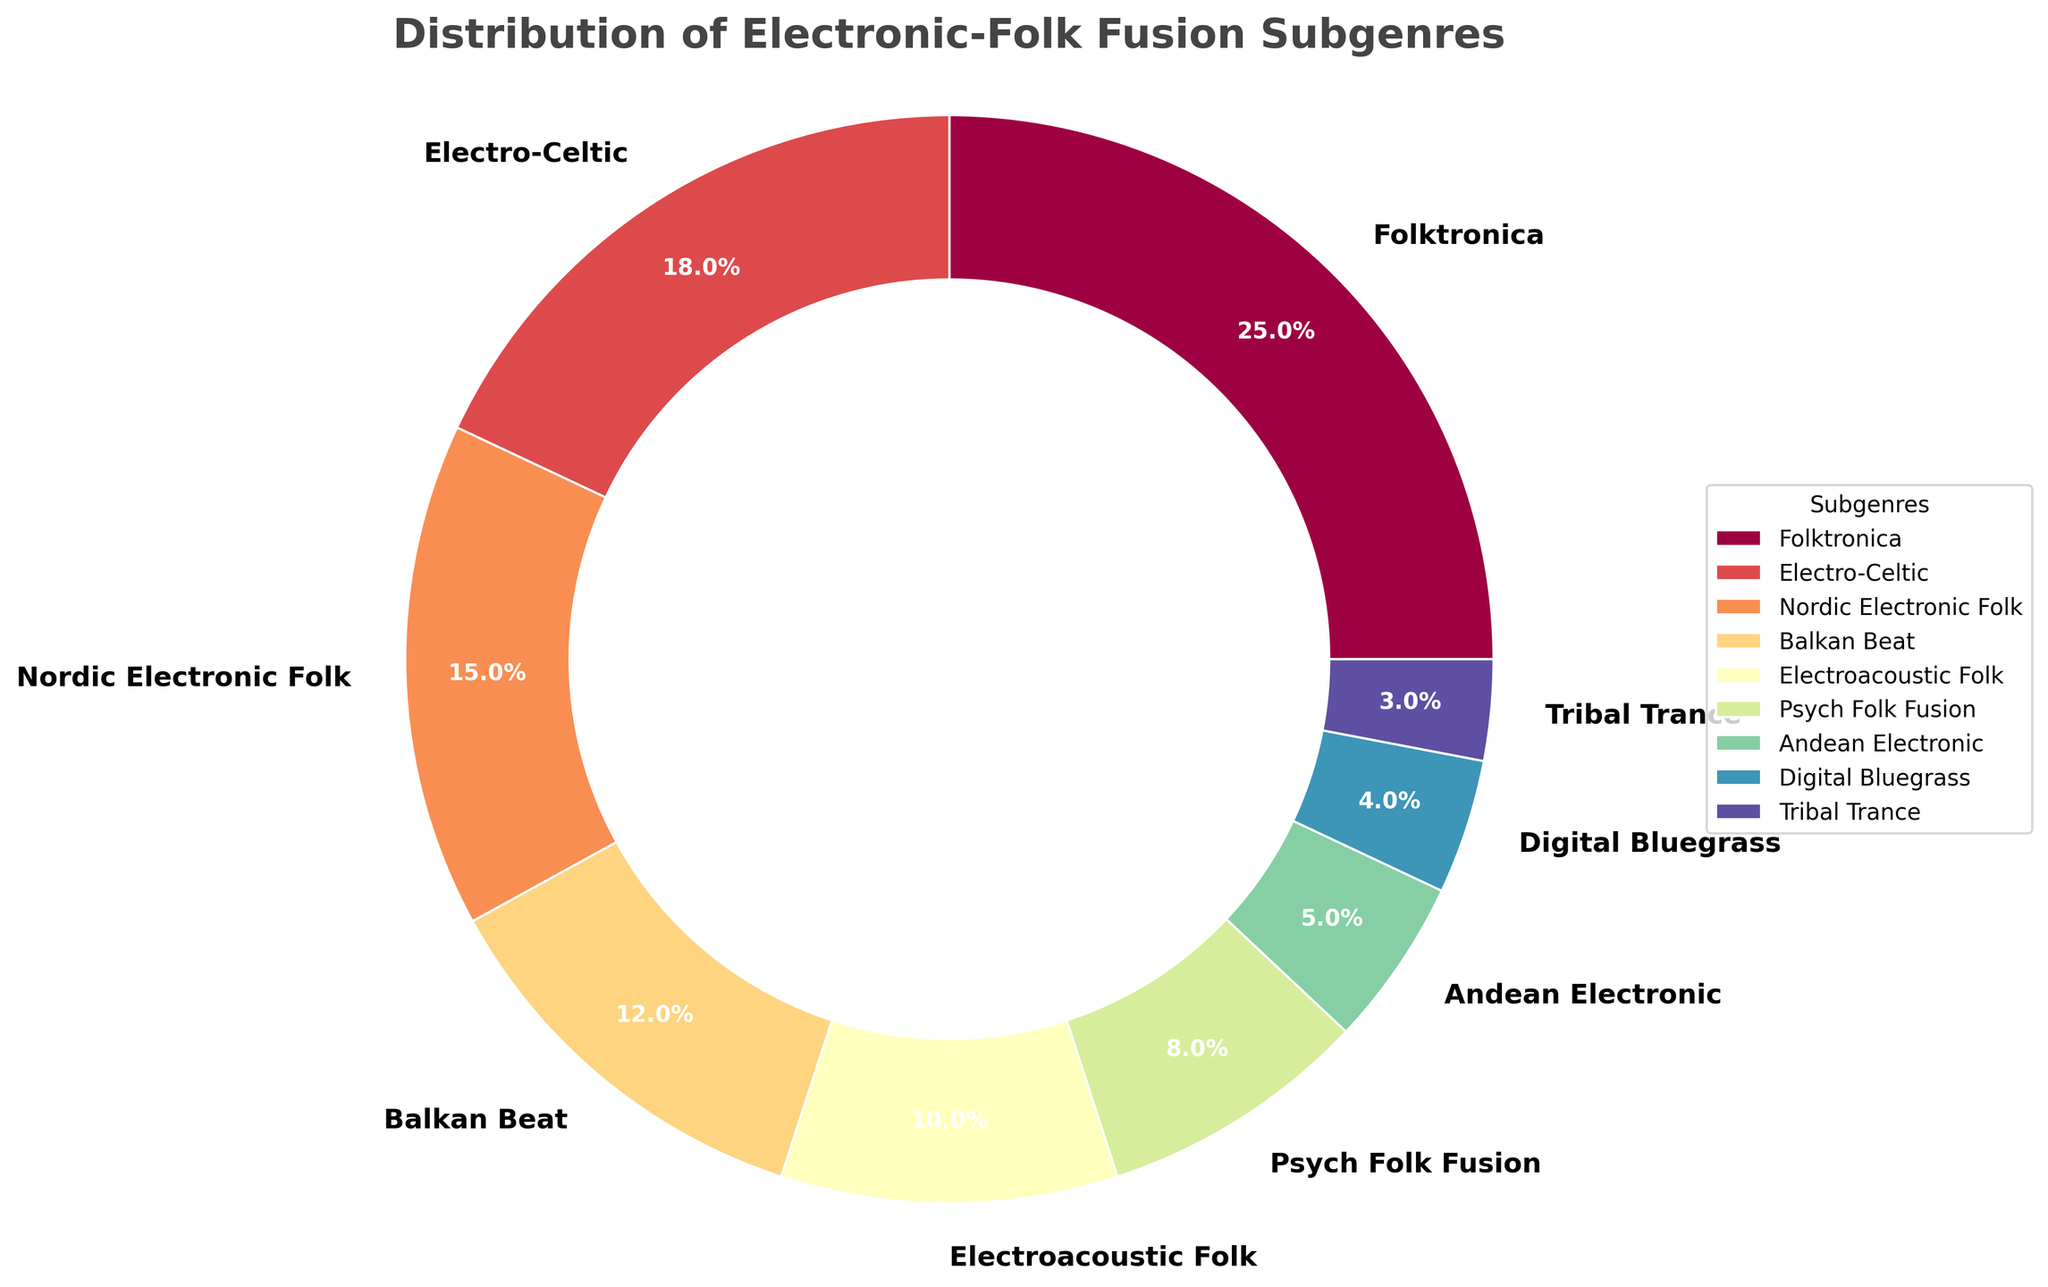Which subgenre has the highest percentage? The subgenre with the largest slice in the pie chart corresponds to Folktronica, which is labeled with the highest percentage.
Answer: Folktronica What is the combined percentage of Electro-Celtic and Nordic Electronic Folk? To find the combined percentage, sum the percentages of Electro-Celtic (18%) and Nordic Electronic Folk (15%). 18% + 15% = 33%
Answer: 33% How much larger is the percentage of Folktronica compared to Electroacoustic Folk? Subtract the percentage of Electroacoustic Folk (10%) from Folktronica (25%). 25% - 10% = 15%
Answer: 15% Which subgenre has the smallest percentage? The subgenre with the smallest slice in the pie chart corresponds to Tribal Trance, which is labeled with the smallest percentage.
Answer: Tribal Trance Are there any subgenres with a percentage less than 5%? If so, which ones? The pie chart shows that both Digital Bluegrass (4%) and Tribal Trance (3%) have percentages less than 5%.
Answer: Digital Bluegrass, Tribal Trance What is the average percentage of all subgenres combined? To find the average percentage, sum all the percentage values and divide by the number of subgenres. (25 + 18 + 15 + 12 + 10 + 8 + 5 + 4 + 3) / 9 = 100 / 9 ≈ 11.11%
Answer: 11.11% How many subgenres have a percentage greater than 10%? Count the subgenres with percentages greater than 10%: Folktronica (25%), Electro-Celtic (18%), Nordic Electronic Folk (15%), and Balkan Beat (12%). There are 4 subgenres.
Answer: 4 What percentage of the subgenres is represented by the combination of the three smallest subgenres? Sum the percentages of Psych Folk Fusion (8%), Andean Electronic (5%), Digital Bluegrass (4%), and Tribal Trance (3%). 8% + 5% + 4% + 3% = 20%
Answer: 20% 